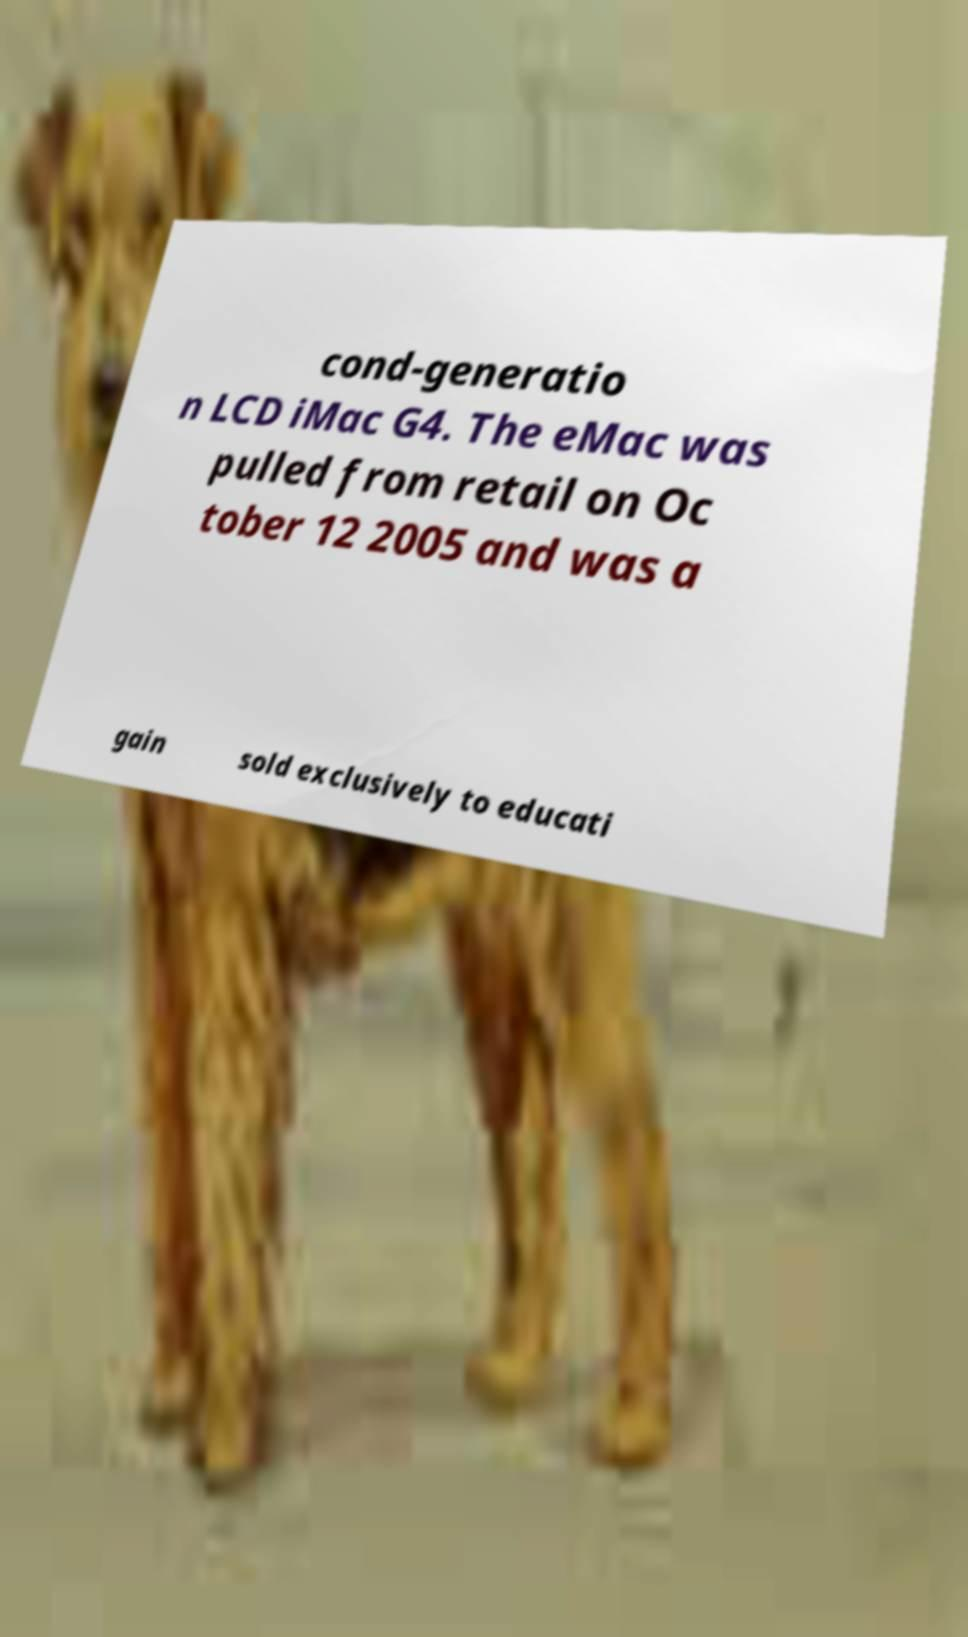What messages or text are displayed in this image? I need them in a readable, typed format. cond-generatio n LCD iMac G4. The eMac was pulled from retail on Oc tober 12 2005 and was a gain sold exclusively to educati 